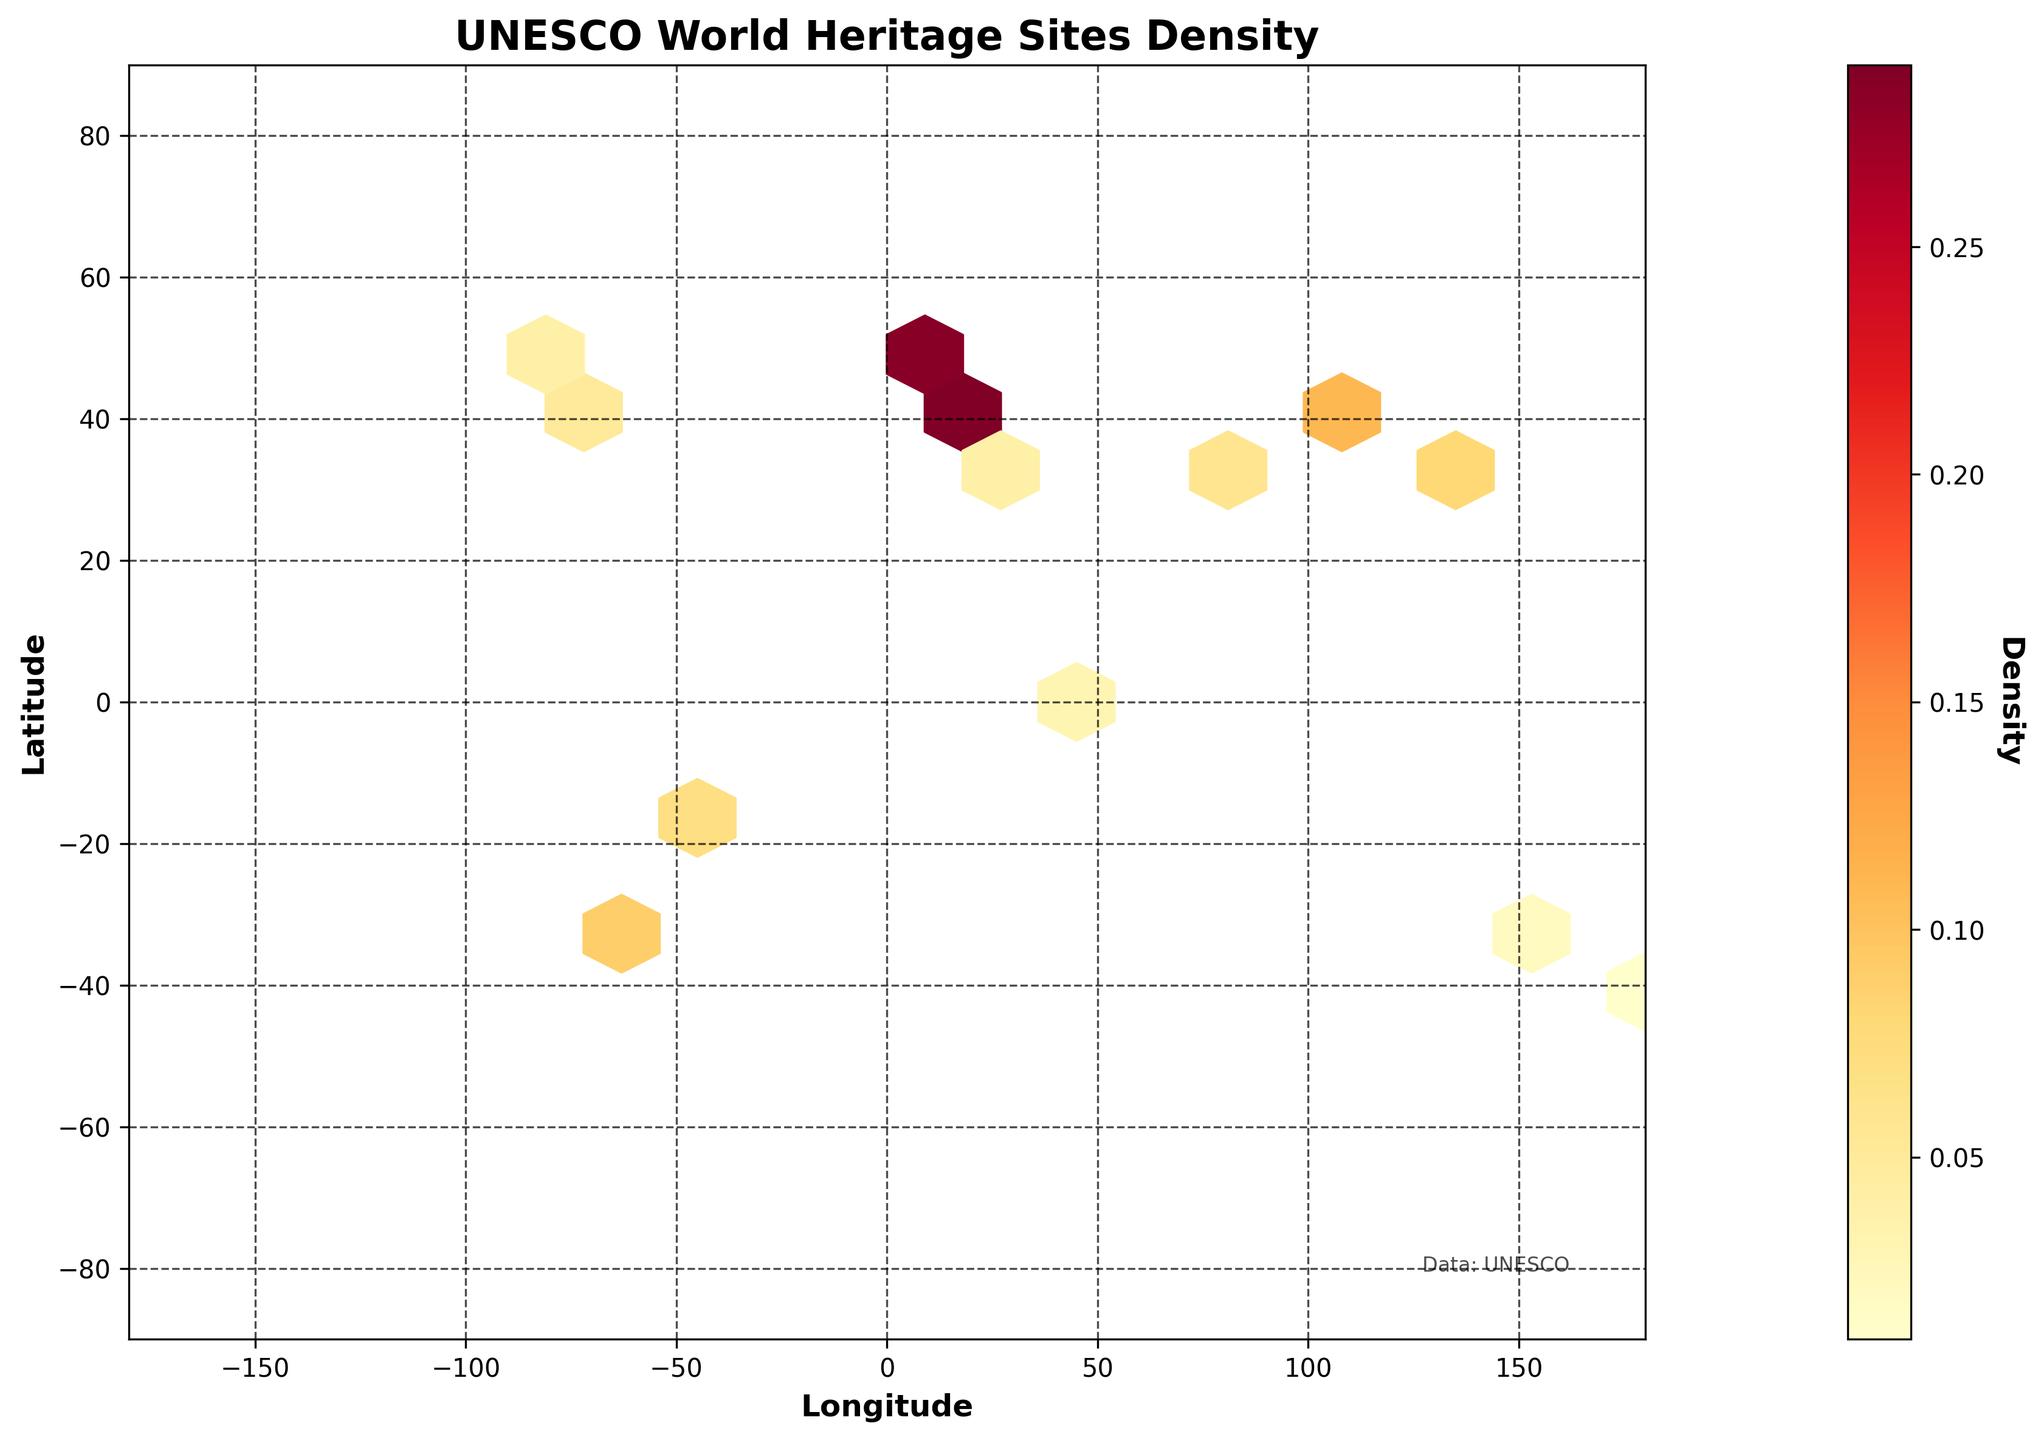what is the title of the figure? The title of the figure is prominently displayed at the top of the plot, and it reads "UNESCO World Heritage Sites Density."
Answer: UNESCO World Heritage Sites Density Which continent has the highest density of UNESCO World Heritage Sites based on the plot? The hexbin plot shows the density with a color gradient from lower density (lighter colors) to higher density (darker colors). Europe has the darkest regions, indicating the highest density of UNESCO World Heritage Sites.
Answer: Europe In which region can the densest cluster of UNESCO sites be found in Asia? The plot indicates density with color gradients. In Asia, the darkest-colored hexagons are centered around the coordinates for Japan (35.6762, 139.6503) and China (39.9042, 116.4074), indicating that these regions have the densest clusters of UNESCO sites.
Answer: Japan and China How does the density of UNESCO World Heritage Sites in South America compare to that in North America? The hexbin plot uses colors to indicate density, with darker colors representing higher densities. The colors in South America are slightly darker compared to those in North America, suggesting that the density of UNESCO World Heritage Sites is higher in South America than in North America.
Answer: Higher in South America What is the approximate density value for the continent with the least density? The plot's color bar indicates the density values. Oceania has the lightest-colored hexagons, representing the lowest density of UNESCO World Heritage Sites. Based on the color gradient and the color bar, the density value in Oceania is around 0.01 to 0.02.
Answer: 0.01 to 0.02 What can you infer about the distribution of UNESCO World Heritage Sites in Africa based on the plot? The hexbin plot shows light to medium-light colors in Africa, indicating a low to moderate density of UNESCO World Heritage Sites. The regions around northern Africa, near Egypt, show slightly higher densities compared to other parts of the continent.
Answer: Low to moderate density Can you identify the colors used in the hexagon bins and what do they represent? The hexbin plot uses a color gradient from light (yellow) to dark (red) within the color map 'YlOrRd.' Light colors represent lower densities, and darker colors represent higher densities of UNESCO World Heritage Sites.
Answer: Light to dark colors (yellow to red) representing low to high densities 